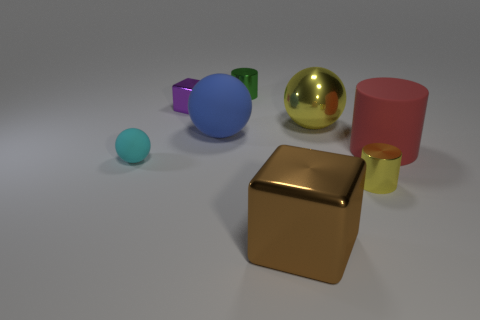Add 2 yellow metal cylinders. How many objects exist? 10 Subtract all cylinders. How many objects are left? 5 Subtract all big yellow metallic spheres. Subtract all blue matte cylinders. How many objects are left? 7 Add 6 cyan balls. How many cyan balls are left? 7 Add 4 green metallic cylinders. How many green metallic cylinders exist? 5 Subtract 1 red cylinders. How many objects are left? 7 